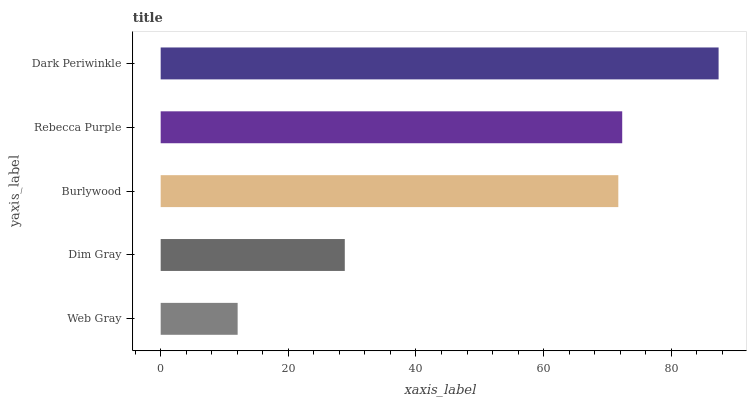Is Web Gray the minimum?
Answer yes or no. Yes. Is Dark Periwinkle the maximum?
Answer yes or no. Yes. Is Dim Gray the minimum?
Answer yes or no. No. Is Dim Gray the maximum?
Answer yes or no. No. Is Dim Gray greater than Web Gray?
Answer yes or no. Yes. Is Web Gray less than Dim Gray?
Answer yes or no. Yes. Is Web Gray greater than Dim Gray?
Answer yes or no. No. Is Dim Gray less than Web Gray?
Answer yes or no. No. Is Burlywood the high median?
Answer yes or no. Yes. Is Burlywood the low median?
Answer yes or no. Yes. Is Rebecca Purple the high median?
Answer yes or no. No. Is Web Gray the low median?
Answer yes or no. No. 